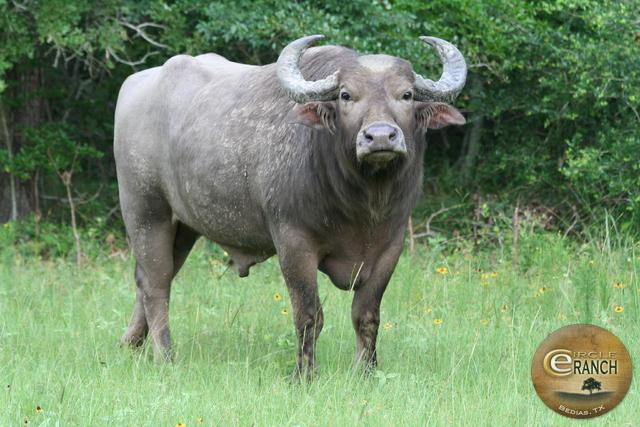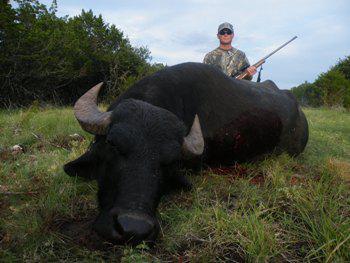The first image is the image on the left, the second image is the image on the right. Considering the images on both sides, is "The left and right image contains the same number of dead bulls." valid? Answer yes or no. No. The first image is the image on the left, the second image is the image on the right. Considering the images on both sides, is "An animal is standing." valid? Answer yes or no. Yes. 